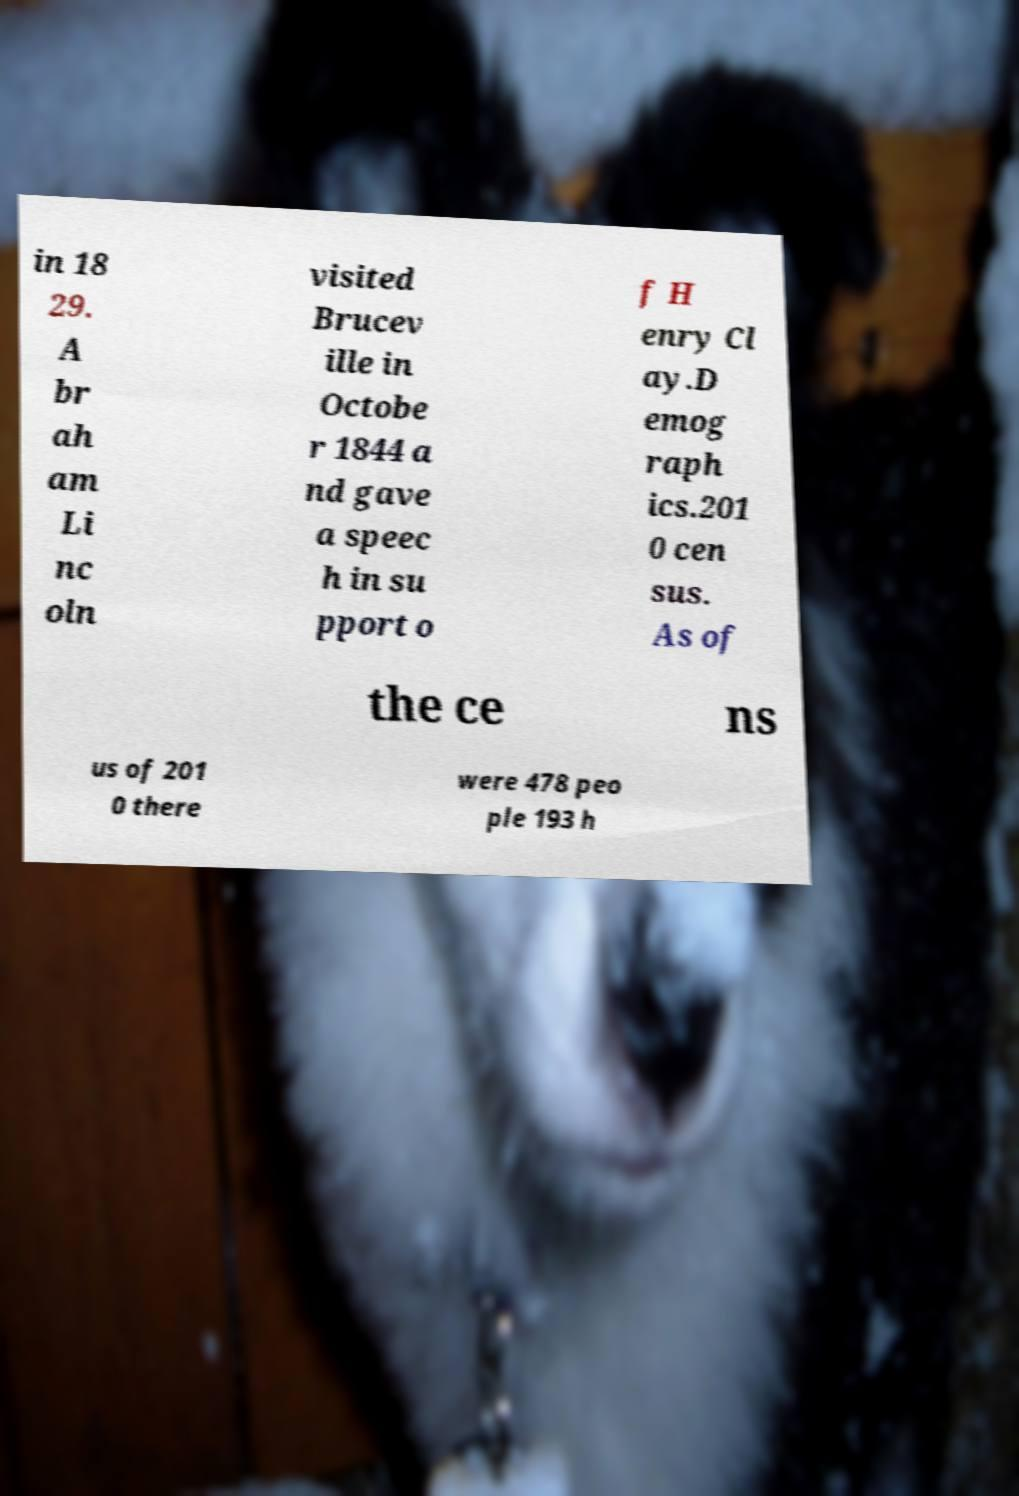What messages or text are displayed in this image? I need them in a readable, typed format. in 18 29. A br ah am Li nc oln visited Brucev ille in Octobe r 1844 a nd gave a speec h in su pport o f H enry Cl ay.D emog raph ics.201 0 cen sus. As of the ce ns us of 201 0 there were 478 peo ple 193 h 